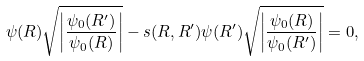Convert formula to latex. <formula><loc_0><loc_0><loc_500><loc_500>\psi ( R ) \sqrt { \left | \frac { \psi _ { \text {0} } ( R ^ { \prime } ) } { \psi _ { \text {0} } ( R ) } \right | } - s ( R , R ^ { \prime } ) \psi ( R ^ { \prime } ) \sqrt { \left | \frac { \psi _ { \text {0} } ( R ) } { \psi _ { \text {0} } ( R ^ { \prime } ) } \right | } = 0 ,</formula> 